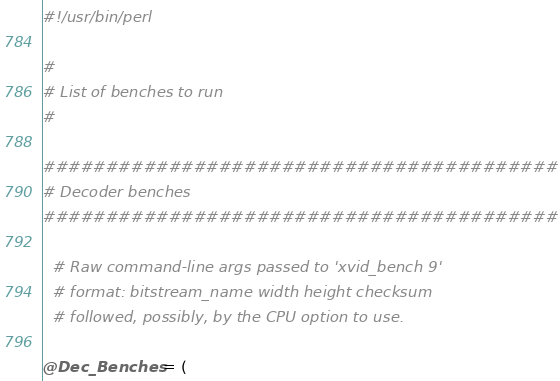Convert code to text. <code><loc_0><loc_0><loc_500><loc_500><_Perl_>#!/usr/bin/perl

#
# List of benches to run
#

#########################################
# Decoder benches
#########################################

  # Raw command-line args passed to 'xvid_bench 9'
  # format: bitstream_name width height checksum
  # followed, possibly, by the CPU option to use.  

@Dec_Benches = (
</code> 